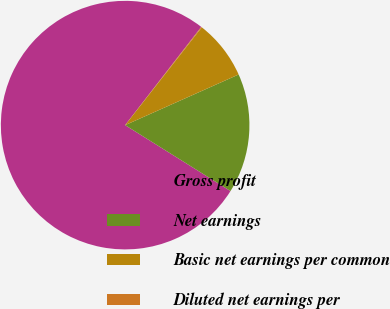<chart> <loc_0><loc_0><loc_500><loc_500><pie_chart><fcel>Gross profit<fcel>Net earnings<fcel>Basic net earnings per common<fcel>Diluted net earnings per<nl><fcel>76.6%<fcel>15.58%<fcel>7.74%<fcel>0.09%<nl></chart> 